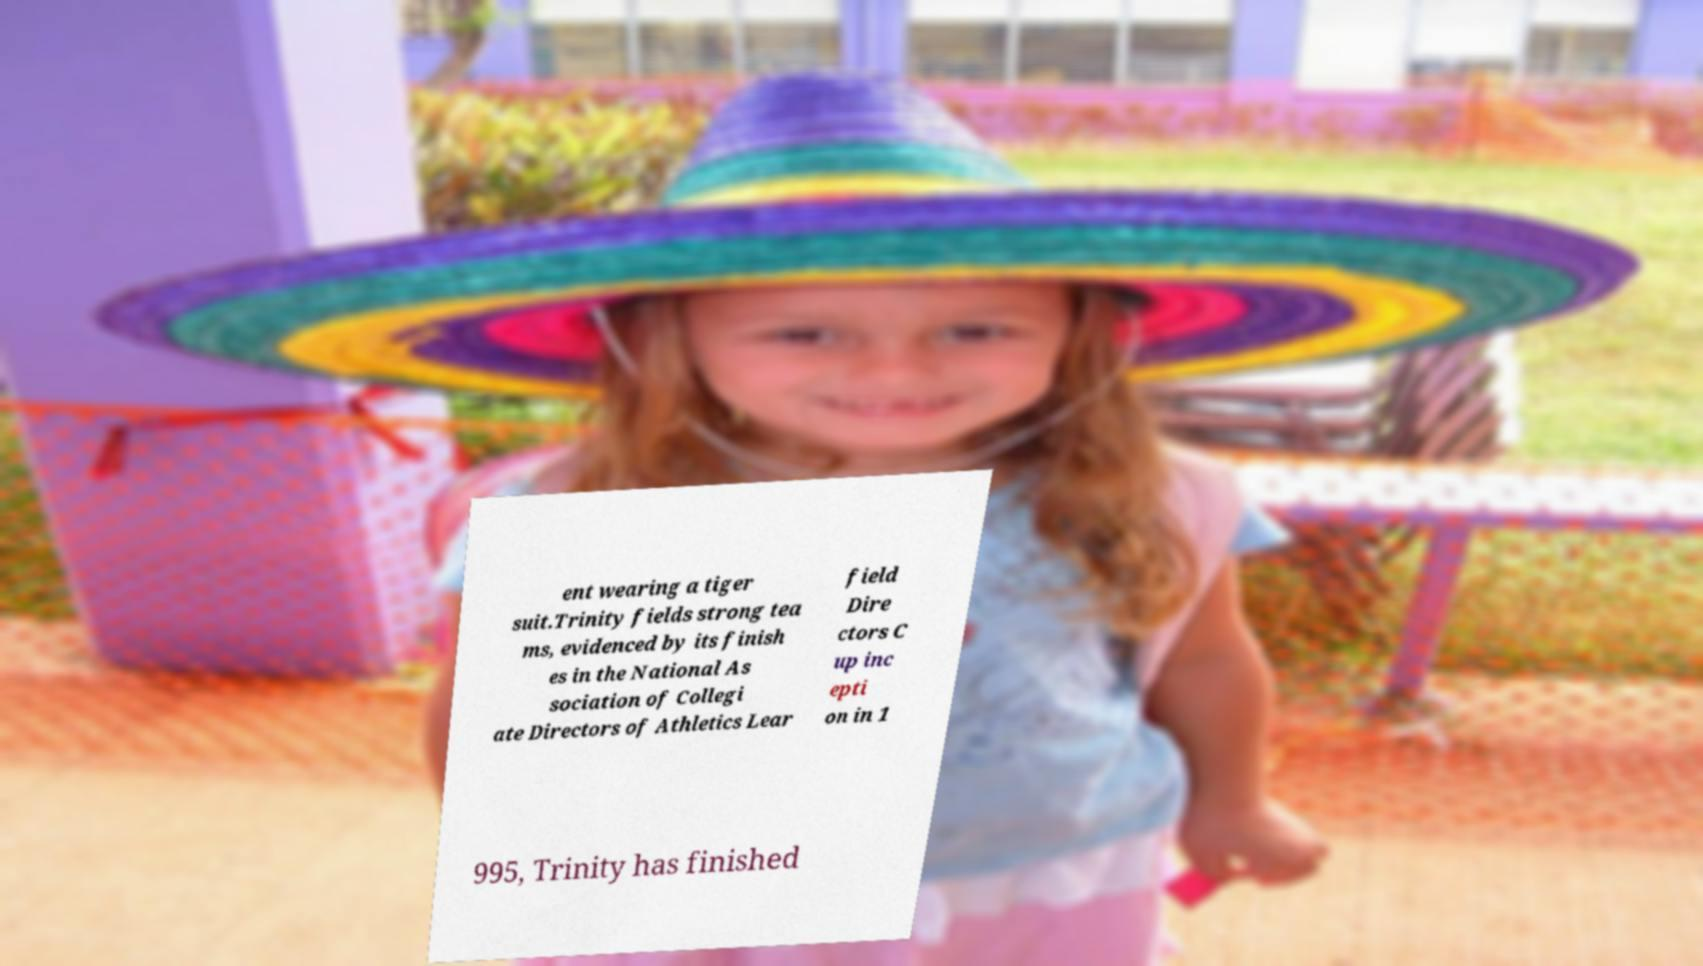Could you assist in decoding the text presented in this image and type it out clearly? ent wearing a tiger suit.Trinity fields strong tea ms, evidenced by its finish es in the National As sociation of Collegi ate Directors of Athletics Lear field Dire ctors C up inc epti on in 1 995, Trinity has finished 